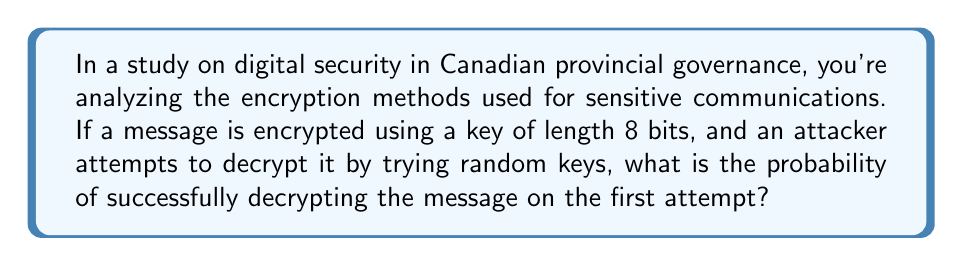Can you answer this question? To solve this problem, we need to follow these steps:

1. Understand the key space:
   - With a key length of 8 bits, there are $2^8$ possible key combinations.
   - This is because each bit can be either 0 or 1, and there are 8 bits.

2. Calculate the total number of possible keys:
   $$\text{Total keys} = 2^8 = 256$$

3. Determine the probability of success:
   - The probability of guessing the correct key on the first attempt is 1 divided by the total number of possible keys.
   - This is because only one key out of all possible keys will be correct.

4. Express the probability mathematically:
   $$P(\text{success}) = \frac{1}{\text{Total keys}} = \frac{1}{256}$$

5. Simplify the fraction if possible (in this case, it's already in its simplest form).

Thus, the probability of successfully decrypting the message on the first attempt is $\frac{1}{256}$.
Answer: $\frac{1}{256}$ 